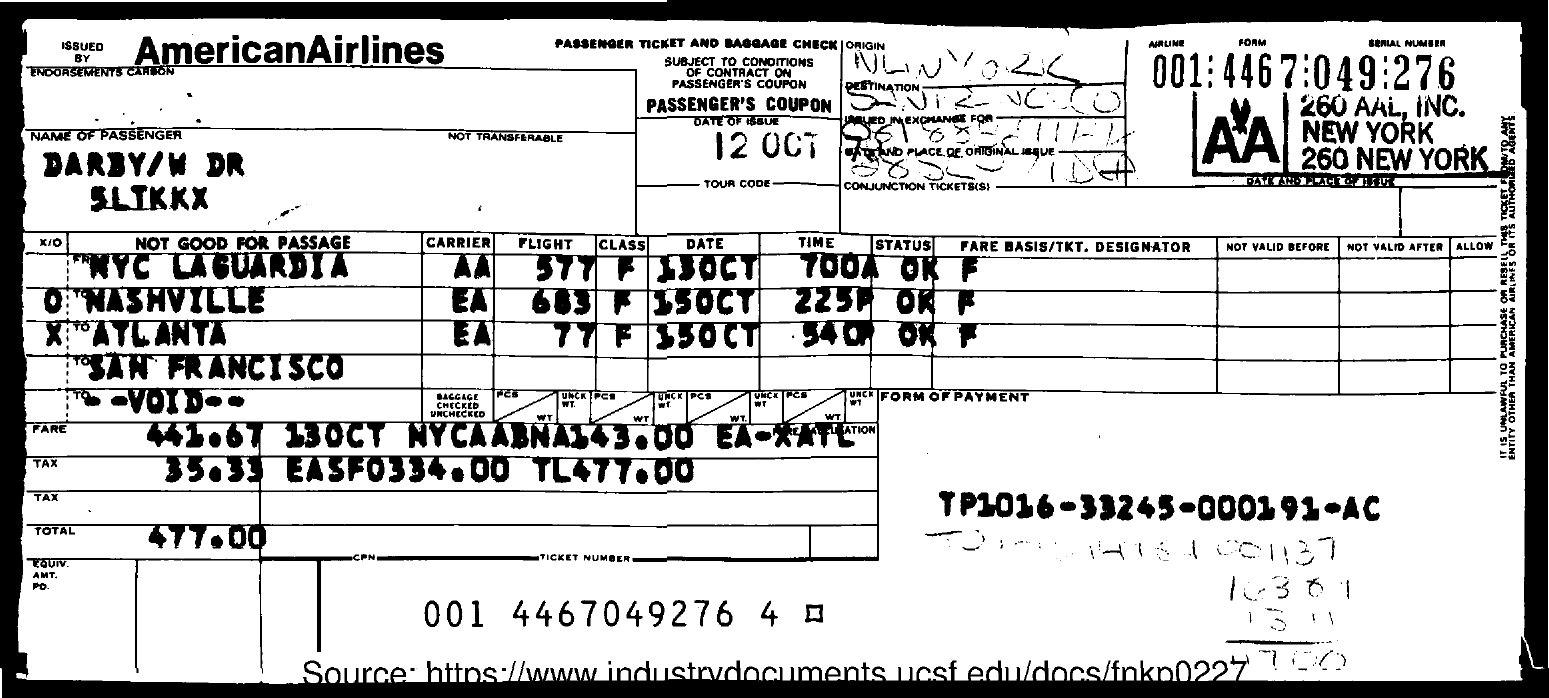What is the Total?
Make the answer very short. 477.00. What is the Ticket Number?
Provide a succinct answer. 001 4467049276 4. What is the Date of Issue?
Provide a short and direct response. 12 OCT. What is the Form of Payment?
Provide a short and direct response. TP1016-33245-000191-AC. 